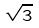<formula> <loc_0><loc_0><loc_500><loc_500>\sqrt { 3 }</formula> 